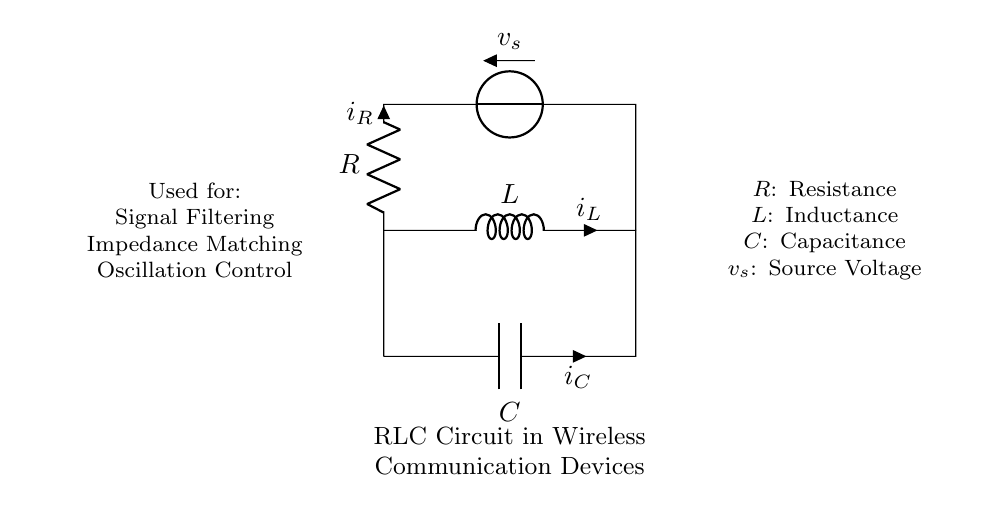What are the components in this circuit? The components are a resistor, an inductor, and a capacitor, as indicated by the labels R, L, and C in the diagram.
Answer: Resistor, Inductor, Capacitor What does the symbol 'v_s' represent? The symbol 'v_s' represents the source voltage in the circuit, which is the voltage supplied to the circuit.
Answer: Source Voltage How many nodes are present in the circuit? There are four nodes in the circuit: one at the bottom connection of the capacitor, one at the top of the resistor, and two at the left and right ends of the inductor.
Answer: Four nodes What is the role of the inductor in this circuit? The inductor plays a role in controlling oscillation and filtering signals, as indicated in the explanation text below the circuit.
Answer: Oscillation Control What type of circuit is illustrated here? The circuit illustrated is an RLC circuit, which stands for Resistor-Inductor-Capacitor circuit specifically used for filtering and impedance matching tasks.
Answer: RLC circuit How are the components connected? The components are connected in a series-parallel configuration, where the inductor is in series with the resistor and both the resistor and capacitor are in parallel to the voltage source.
Answer: Series-Parallel Configuration What function does the capacitor serve in this circuit? The capacitor primarily serves for signal filtering and impedance matching, as noted in the diagram's description.
Answer: Signal Filtering and Impedance Matching 